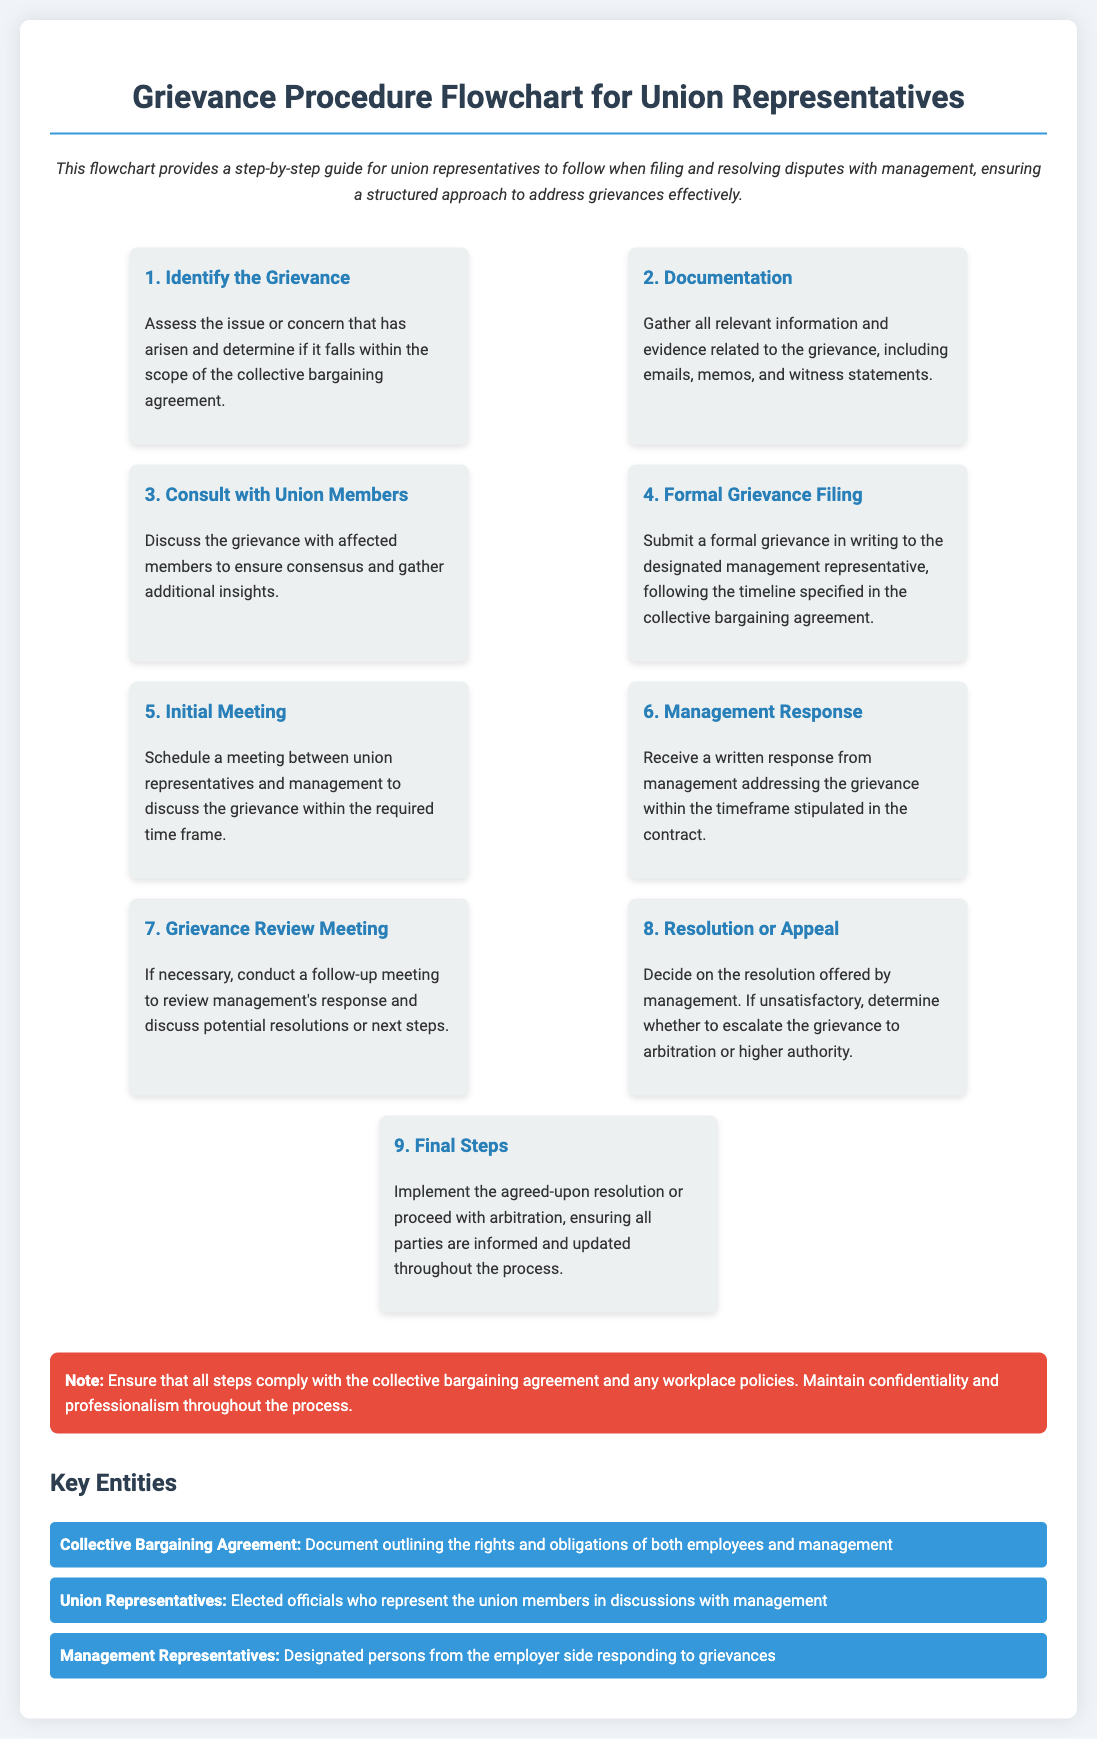What is the first step in the grievance procedure? The first step in the grievance procedure is to identify the grievance by assessing the issue or concern that has arisen.
Answer: Identify the Grievance How many steps are there in the grievance procedure? The document outlines a total of nine steps in the grievance procedure flowchart.
Answer: Nine What is required during the documentation step? During the documentation step, all relevant information and evidence related to the grievance must be gathered, including emails and witness statements.
Answer: Gather all relevant information and evidence What must be submitted to management during the formal grievance filing? A formal grievance must be submitted in writing to the designated management representative.
Answer: Formal grievance in writing What is the purpose of the initial meeting? The initial meeting is to schedule a discussion between union representatives and management regarding the grievance.
Answer: Discuss the grievance What happens if the management response is unsatisfactory? If the management response is unsatisfactory, the union must decide whether to escalate the grievance.
Answer: Escalate the grievance What should the final steps ensure? The final steps should ensure that all parties are informed and updated throughout the grievance resolution process.
Answer: All parties are informed and updated What documents outline the rights and obligations of employees and management? The collective bargaining agreement is the document outlining the rights and obligations.
Answer: Collective Bargaining Agreement Who represents the union members in discussions with management? Union representatives are the elected officials who represent the union members.
Answer: Union Representatives 